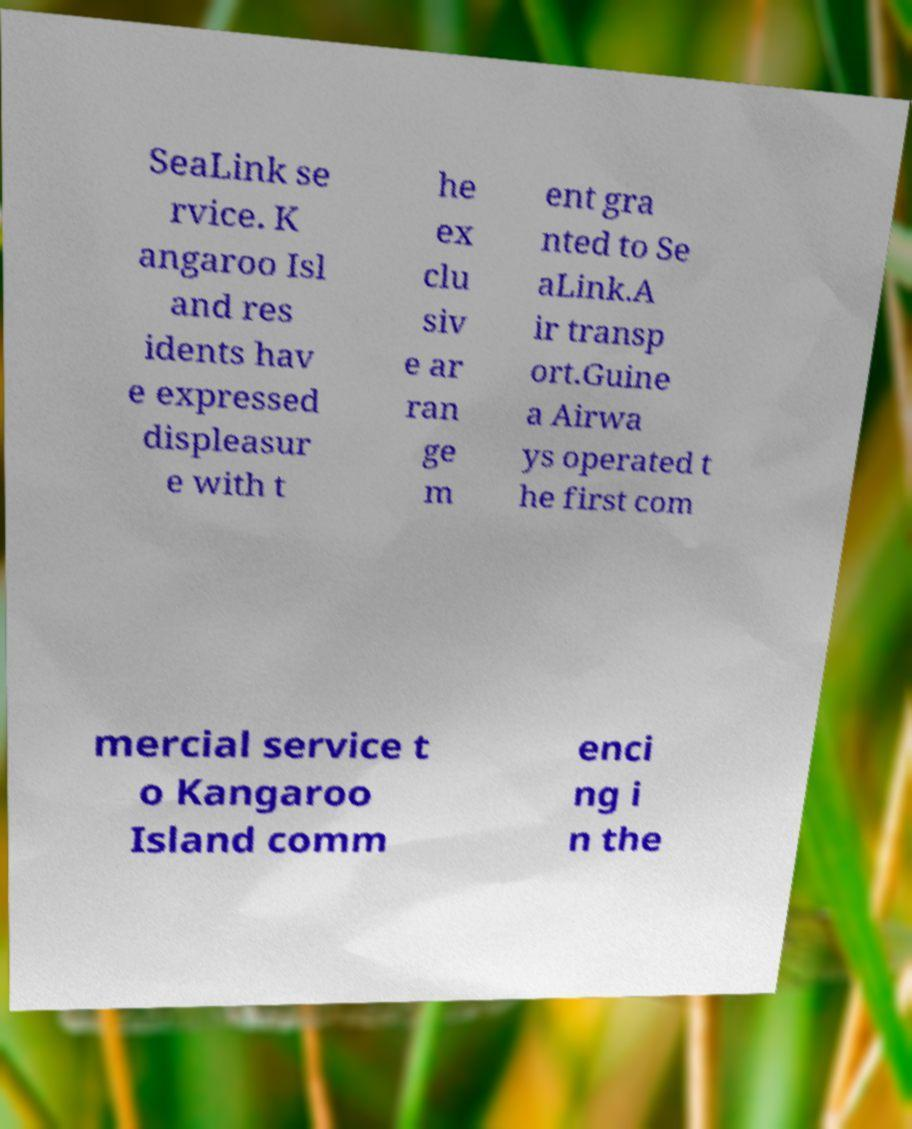Could you assist in decoding the text presented in this image and type it out clearly? SeaLink se rvice. K angaroo Isl and res idents hav e expressed displeasur e with t he ex clu siv e ar ran ge m ent gra nted to Se aLink.A ir transp ort.Guine a Airwa ys operated t he first com mercial service t o Kangaroo Island comm enci ng i n the 